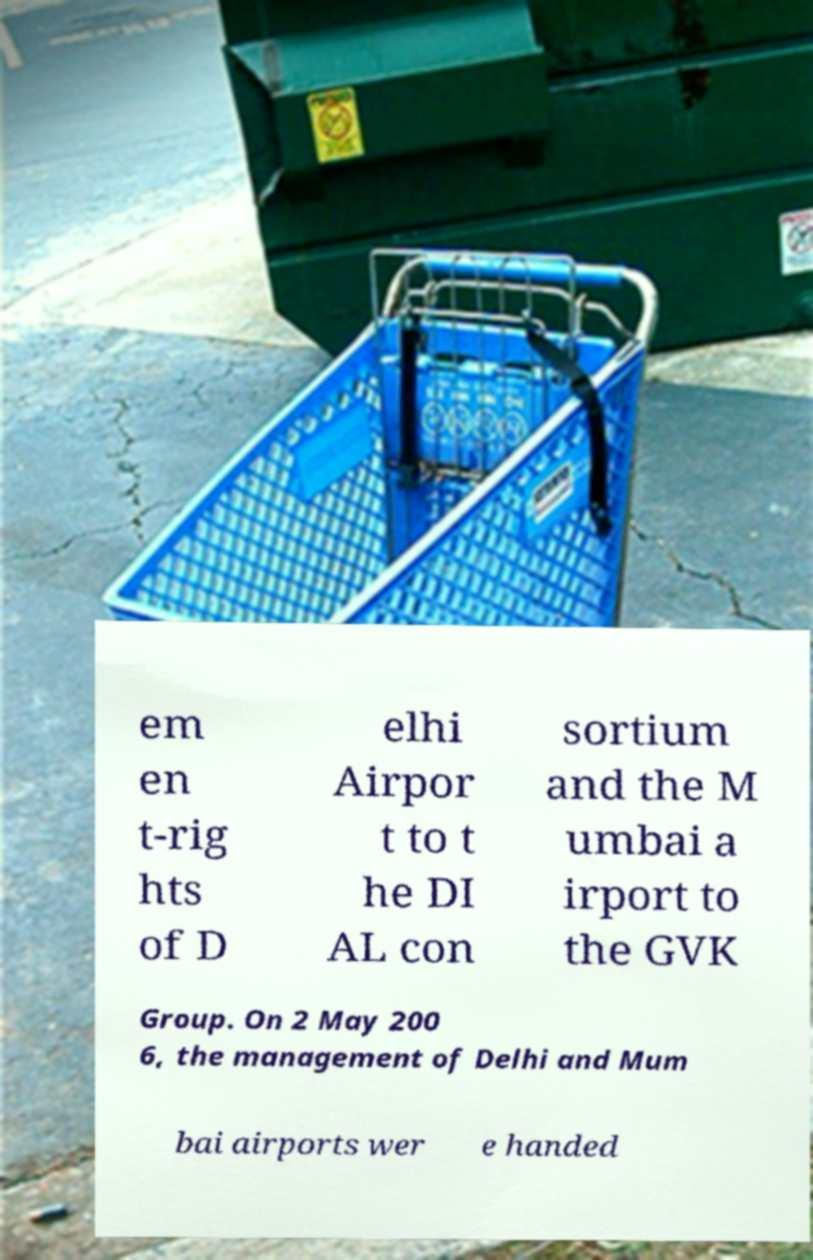Can you read and provide the text displayed in the image?This photo seems to have some interesting text. Can you extract and type it out for me? em en t-rig hts of D elhi Airpor t to t he DI AL con sortium and the M umbai a irport to the GVK Group. On 2 May 200 6, the management of Delhi and Mum bai airports wer e handed 